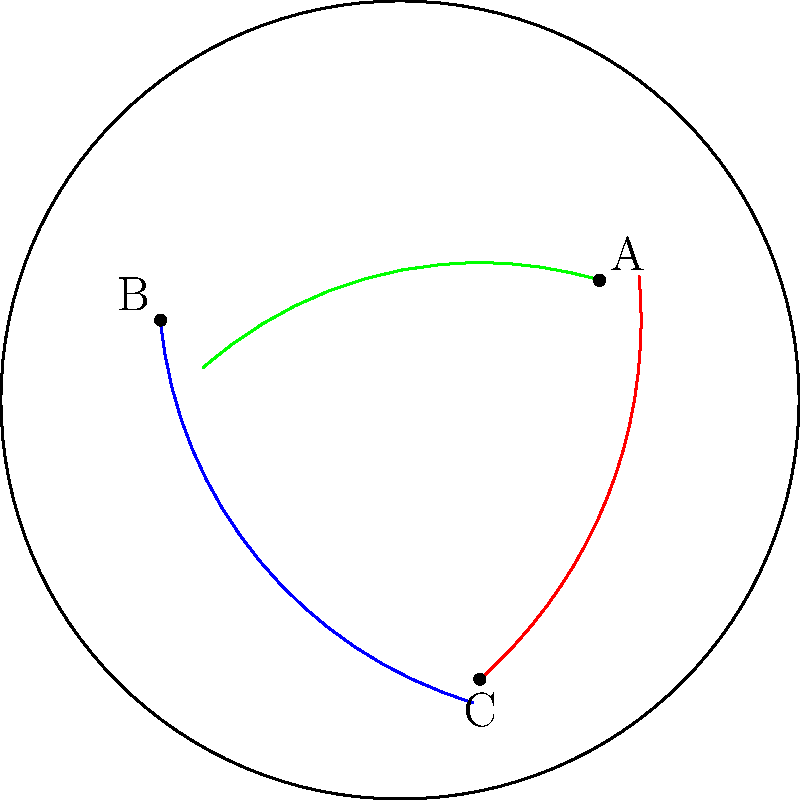In the Poincaré disk model of hyperbolic geometry shown above, three geodesics (hyperbolic lines) are depicted in blue, red, and green. How does this visualization demonstrate the curvature of a hyperbolic plane, and what implications might this have for understanding the spread of information in non-Euclidean network structures in media and political communication? To understand how this visualization demonstrates the curvature of a hyperbolic plane and its implications for media and political communication, let's break it down step-by-step:

1. Poincaré disk model: The circle represents the entire hyperbolic plane, with the interior of the disk representing infinite space.

2. Geodesics (hyperbolic lines): 
   - In Euclidean geometry, the shortest path between two points is a straight line.
   - In the Poincaré disk model, geodesics appear as arcs of circles that intersect the boundary of the disk at right angles.

3. Curvature demonstration:
   - The blue, red, and green arcs represent the shortest paths between points A, B, and C.
   - Their curved nature illustrates the negative curvature of hyperbolic space.
   - As geodesics approach the disk's boundary, they become more curved, representing distances approaching infinity.

4. Implications for media and political communication:
   - Network structures: In hyperbolic space, the number of nodes at a given distance from a central point grows exponentially, unlike in Euclidean space where it grows polynomially.
   - Information spread: This property can model how information spreads rapidly in certain network structures, such as social media.
   - Clustering: Hyperbolic geometry allows for natural clustering of information, which could represent echo chambers or information silos in media landscapes.
   - Distance perception: The curved nature of geodesics suggests that perceived distances in information networks might differ from actual topological distances.

5. Research opportunities:
   - Studying how the curvature of information spaces affects the dissemination of political messages.
   - Analyzing the formation and evolution of opinion clusters in hyperbolic-like network structures.
   - Investigating how the non-Euclidean nature of online social networks impacts political polarization and consensus-building.

Understanding these non-Euclidean properties can provide insights into the complex dynamics of information flow in modern media and political communication systems.
Answer: The curved geodesics visualize hyperbolic curvature, implying exponential network growth and non-intuitive distance relationships in information spread, potentially explaining rapid dissemination and clustering in media and political communication networks. 